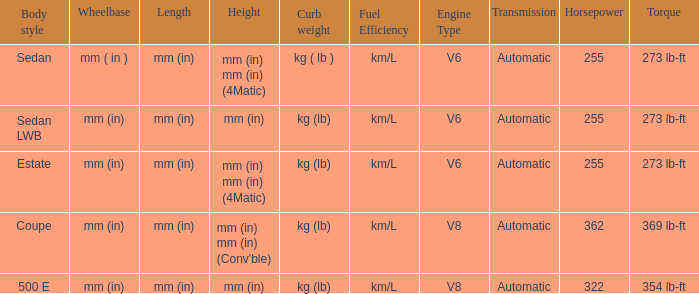What's the curb weight of the model with a wheelbase of mm (in) and height of mm (in) mm (in) (4Matic)? Kg ( lb ), kg (lb). 